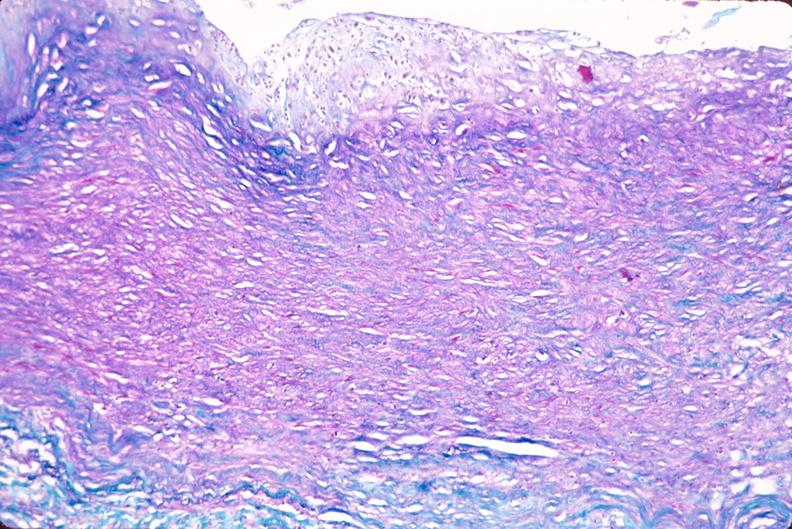s cardiovascular present?
Answer the question using a single word or phrase. Yes 